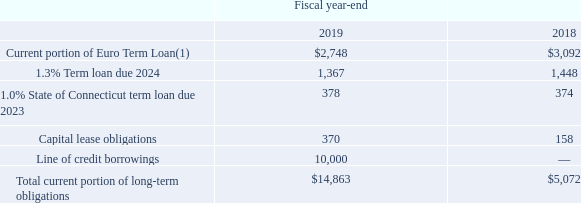Short-term borrowings and current portion of long-term obligations consist of the following (in thousands):
(1) Net of debt issuance costs of $4.6 million and $4.7 million at September 28, 2019 and September 29, 2018, respectively.
What does the Current portion of Euro Term Loan consist of? (1) net of debt issuance costs of $4.6 million and $4.7 million at september 28, 2019 and september 29, 2018, respectively. What was the amount of Line of credit borrowings in 2019?
Answer scale should be: thousand. 10,000. In which years was the Total current portion of long-term obligations calculated? 2019, 2018. In which year was the 1.0% State of Connecticut term loan due 2023 larger? 378>374
Answer: 2019. What was the change in Capital lease obligations from 2018 to 2019?
Answer scale should be: thousand. 370-158
Answer: 212. What was the percentage change in Capital lease obligations from 2018 to 2019?
Answer scale should be: percent. (370-158)/158
Answer: 134.18. 